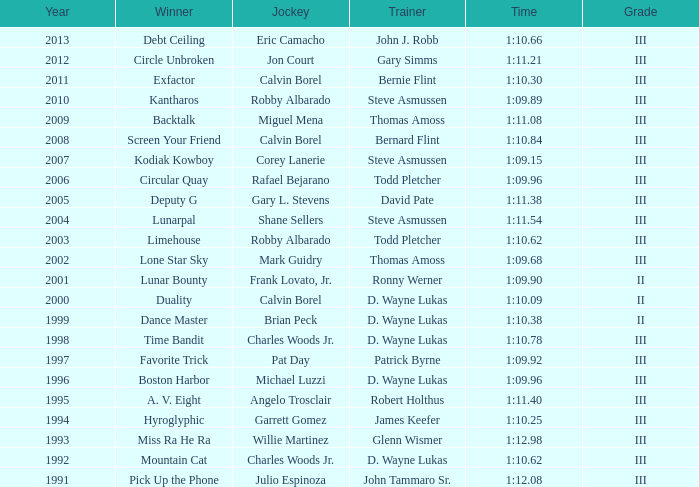Who was the trainer that recorded a 1:10.09 time in a year earlier than 2009? D. Wayne Lukas. 